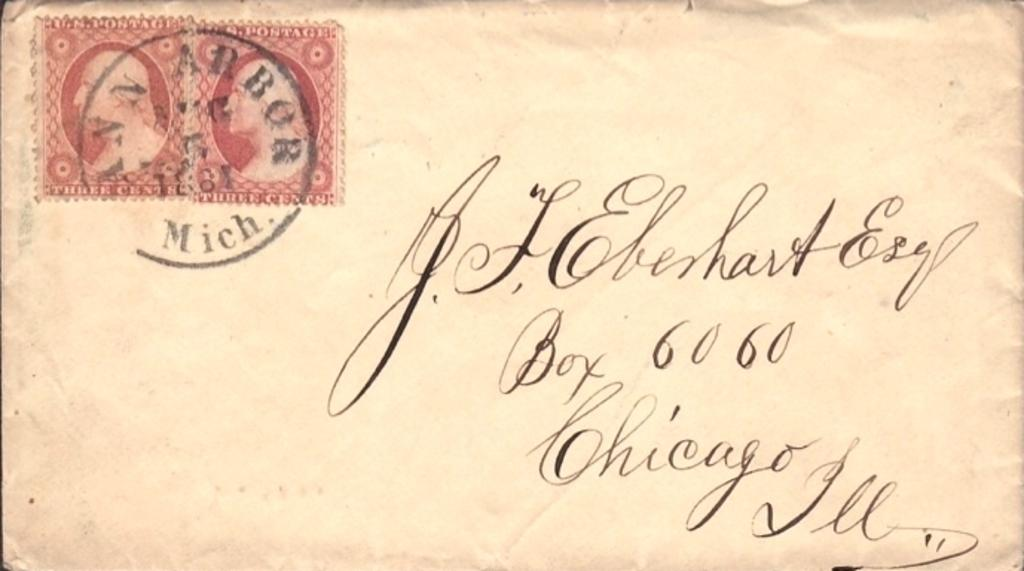<image>
Present a compact description of the photo's key features. Envelope that has the number 6060 on it and the city of Chicago. 